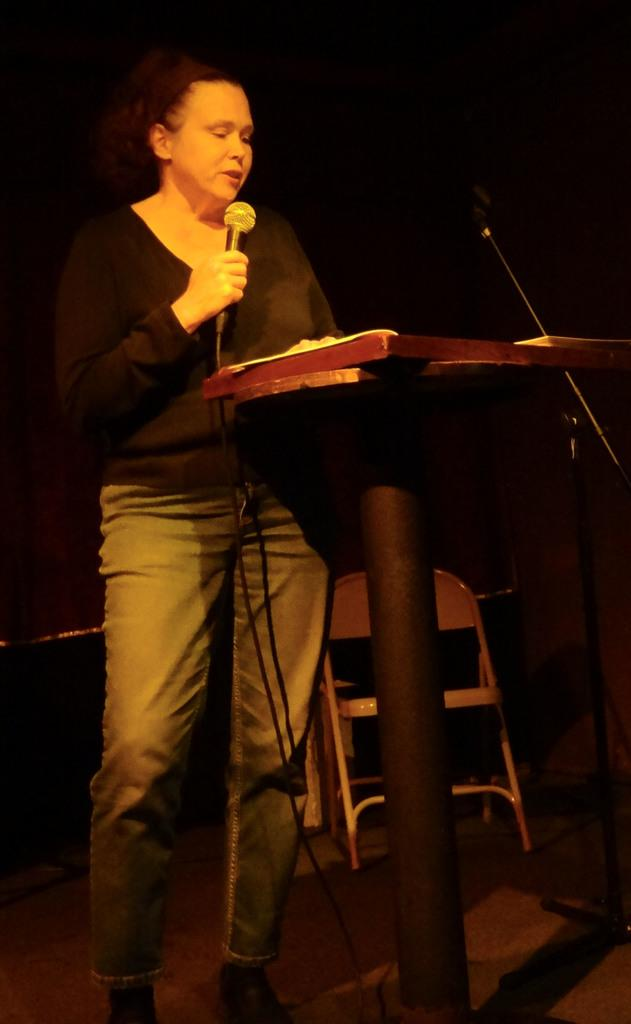Who is the main subject in the image? There is a woman in the image. What is the woman holding in the image? The woman is holding a mic. What object is in front of the woman? There is a podium in front of the woman. What furniture can be seen in the background of the image? There is a chair in the background of the image. What other audio equipment is visible in the image? There is a microphone in the background of the image. How would you describe the lighting in the image? The background of the image is dark. What type of garden can be seen in the background of the image? There is no garden present in the image; the background is dark. What type of dinner is being served in the image? There is no dinner present in the image; the woman is holding a mic and standing in front of a podium. 